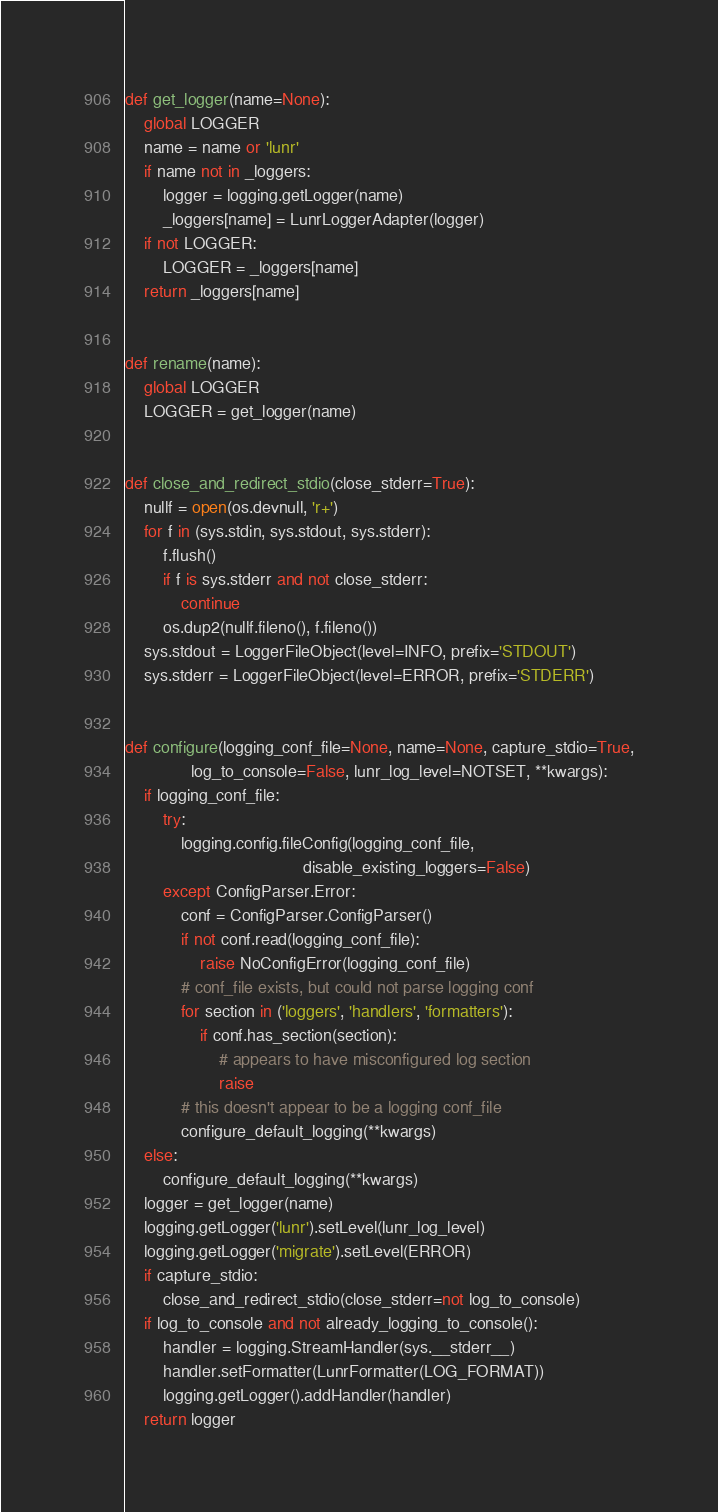Convert code to text. <code><loc_0><loc_0><loc_500><loc_500><_Python_>

def get_logger(name=None):
    global LOGGER
    name = name or 'lunr'
    if name not in _loggers:
        logger = logging.getLogger(name)
        _loggers[name] = LunrLoggerAdapter(logger)
    if not LOGGER:
        LOGGER = _loggers[name]
    return _loggers[name]


def rename(name):
    global LOGGER
    LOGGER = get_logger(name)


def close_and_redirect_stdio(close_stderr=True):
    nullf = open(os.devnull, 'r+')
    for f in (sys.stdin, sys.stdout, sys.stderr):
        f.flush()
        if f is sys.stderr and not close_stderr:
            continue
        os.dup2(nullf.fileno(), f.fileno())
    sys.stdout = LoggerFileObject(level=INFO, prefix='STDOUT')
    sys.stderr = LoggerFileObject(level=ERROR, prefix='STDERR')


def configure(logging_conf_file=None, name=None, capture_stdio=True,
              log_to_console=False, lunr_log_level=NOTSET, **kwargs):
    if logging_conf_file:
        try:
            logging.config.fileConfig(logging_conf_file,
                                      disable_existing_loggers=False)
        except ConfigParser.Error:
            conf = ConfigParser.ConfigParser()
            if not conf.read(logging_conf_file):
                raise NoConfigError(logging_conf_file)
            # conf_file exists, but could not parse logging conf
            for section in ('loggers', 'handlers', 'formatters'):
                if conf.has_section(section):
                    # appears to have misconfigured log section
                    raise
            # this doesn't appear to be a logging conf_file
            configure_default_logging(**kwargs)
    else:
        configure_default_logging(**kwargs)
    logger = get_logger(name)
    logging.getLogger('lunr').setLevel(lunr_log_level)
    logging.getLogger('migrate').setLevel(ERROR)
    if capture_stdio:
        close_and_redirect_stdio(close_stderr=not log_to_console)
    if log_to_console and not already_logging_to_console():
        handler = logging.StreamHandler(sys.__stderr__)
        handler.setFormatter(LunrFormatter(LOG_FORMAT))
        logging.getLogger().addHandler(handler)
    return logger
</code> 